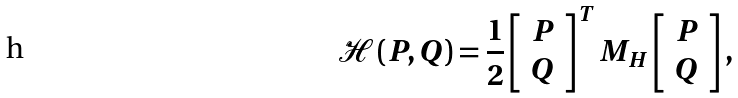<formula> <loc_0><loc_0><loc_500><loc_500>\mathcal { H } \left ( P , Q \right ) = \frac { 1 } { 2 } \left [ \begin{array} [ c ] { l } P \\ Q \end{array} \right ] ^ { T } M _ { H } \left [ \begin{array} [ c ] { l } P \\ Q \end{array} \right ] ,</formula> 